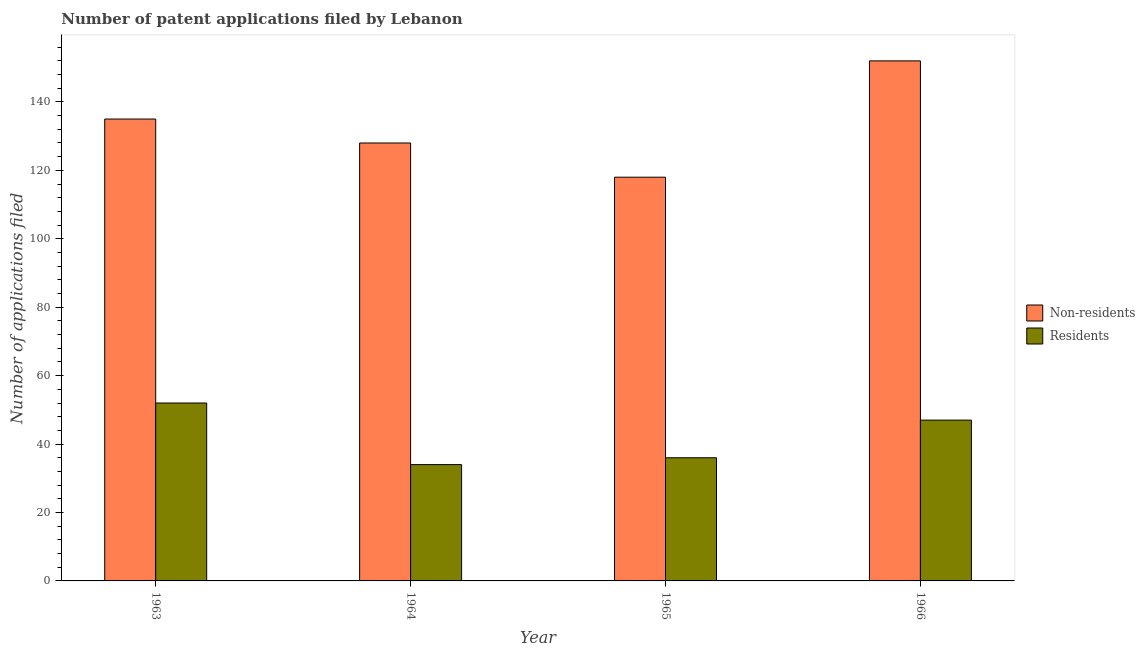How many different coloured bars are there?
Ensure brevity in your answer.  2. How many groups of bars are there?
Your answer should be very brief. 4. How many bars are there on the 1st tick from the left?
Offer a very short reply. 2. How many bars are there on the 2nd tick from the right?
Provide a short and direct response. 2. What is the label of the 3rd group of bars from the left?
Your answer should be very brief. 1965. What is the number of patent applications by non residents in 1965?
Your response must be concise. 118. Across all years, what is the maximum number of patent applications by residents?
Your answer should be very brief. 52. Across all years, what is the minimum number of patent applications by residents?
Offer a terse response. 34. In which year was the number of patent applications by residents maximum?
Offer a terse response. 1963. In which year was the number of patent applications by residents minimum?
Offer a very short reply. 1964. What is the total number of patent applications by residents in the graph?
Your response must be concise. 169. What is the difference between the number of patent applications by non residents in 1965 and that in 1966?
Your answer should be compact. -34. What is the difference between the number of patent applications by residents in 1965 and the number of patent applications by non residents in 1966?
Offer a very short reply. -11. What is the average number of patent applications by non residents per year?
Your answer should be compact. 133.25. What is the ratio of the number of patent applications by non residents in 1963 to that in 1965?
Make the answer very short. 1.14. Is the number of patent applications by non residents in 1964 less than that in 1965?
Make the answer very short. No. What is the difference between the highest and the second highest number of patent applications by residents?
Provide a short and direct response. 5. What is the difference between the highest and the lowest number of patent applications by non residents?
Offer a very short reply. 34. What does the 2nd bar from the left in 1964 represents?
Ensure brevity in your answer.  Residents. What does the 2nd bar from the right in 1966 represents?
Give a very brief answer. Non-residents. How many bars are there?
Your answer should be very brief. 8. What is the difference between two consecutive major ticks on the Y-axis?
Keep it short and to the point. 20. Are the values on the major ticks of Y-axis written in scientific E-notation?
Ensure brevity in your answer.  No. Does the graph contain any zero values?
Make the answer very short. No. Does the graph contain grids?
Offer a very short reply. No. How are the legend labels stacked?
Make the answer very short. Vertical. What is the title of the graph?
Keep it short and to the point. Number of patent applications filed by Lebanon. Does "Resident workers" appear as one of the legend labels in the graph?
Give a very brief answer. No. What is the label or title of the Y-axis?
Give a very brief answer. Number of applications filed. What is the Number of applications filed in Non-residents in 1963?
Give a very brief answer. 135. What is the Number of applications filed in Non-residents in 1964?
Your response must be concise. 128. What is the Number of applications filed in Residents in 1964?
Your response must be concise. 34. What is the Number of applications filed of Non-residents in 1965?
Offer a terse response. 118. What is the Number of applications filed of Non-residents in 1966?
Provide a short and direct response. 152. What is the Number of applications filed in Residents in 1966?
Make the answer very short. 47. Across all years, what is the maximum Number of applications filed in Non-residents?
Provide a short and direct response. 152. Across all years, what is the minimum Number of applications filed in Non-residents?
Offer a very short reply. 118. What is the total Number of applications filed of Non-residents in the graph?
Provide a succinct answer. 533. What is the total Number of applications filed in Residents in the graph?
Your response must be concise. 169. What is the difference between the Number of applications filed of Non-residents in 1963 and that in 1964?
Make the answer very short. 7. What is the difference between the Number of applications filed in Residents in 1963 and that in 1965?
Offer a terse response. 16. What is the difference between the Number of applications filed of Non-residents in 1963 and that in 1966?
Give a very brief answer. -17. What is the difference between the Number of applications filed of Residents in 1963 and that in 1966?
Make the answer very short. 5. What is the difference between the Number of applications filed in Residents in 1964 and that in 1966?
Ensure brevity in your answer.  -13. What is the difference between the Number of applications filed in Non-residents in 1965 and that in 1966?
Offer a terse response. -34. What is the difference between the Number of applications filed in Residents in 1965 and that in 1966?
Give a very brief answer. -11. What is the difference between the Number of applications filed in Non-residents in 1963 and the Number of applications filed in Residents in 1964?
Offer a very short reply. 101. What is the difference between the Number of applications filed in Non-residents in 1963 and the Number of applications filed in Residents in 1965?
Offer a very short reply. 99. What is the difference between the Number of applications filed of Non-residents in 1964 and the Number of applications filed of Residents in 1965?
Your answer should be compact. 92. What is the average Number of applications filed of Non-residents per year?
Your answer should be very brief. 133.25. What is the average Number of applications filed in Residents per year?
Provide a succinct answer. 42.25. In the year 1963, what is the difference between the Number of applications filed in Non-residents and Number of applications filed in Residents?
Your answer should be compact. 83. In the year 1964, what is the difference between the Number of applications filed of Non-residents and Number of applications filed of Residents?
Your answer should be compact. 94. In the year 1966, what is the difference between the Number of applications filed in Non-residents and Number of applications filed in Residents?
Keep it short and to the point. 105. What is the ratio of the Number of applications filed of Non-residents in 1963 to that in 1964?
Your answer should be very brief. 1.05. What is the ratio of the Number of applications filed in Residents in 1963 to that in 1964?
Provide a short and direct response. 1.53. What is the ratio of the Number of applications filed in Non-residents in 1963 to that in 1965?
Provide a short and direct response. 1.14. What is the ratio of the Number of applications filed of Residents in 1963 to that in 1965?
Provide a short and direct response. 1.44. What is the ratio of the Number of applications filed of Non-residents in 1963 to that in 1966?
Give a very brief answer. 0.89. What is the ratio of the Number of applications filed of Residents in 1963 to that in 1966?
Ensure brevity in your answer.  1.11. What is the ratio of the Number of applications filed of Non-residents in 1964 to that in 1965?
Your answer should be compact. 1.08. What is the ratio of the Number of applications filed of Non-residents in 1964 to that in 1966?
Your response must be concise. 0.84. What is the ratio of the Number of applications filed of Residents in 1964 to that in 1966?
Make the answer very short. 0.72. What is the ratio of the Number of applications filed of Non-residents in 1965 to that in 1966?
Offer a terse response. 0.78. What is the ratio of the Number of applications filed in Residents in 1965 to that in 1966?
Your response must be concise. 0.77. What is the difference between the highest and the second highest Number of applications filed in Non-residents?
Your response must be concise. 17. What is the difference between the highest and the lowest Number of applications filed in Non-residents?
Give a very brief answer. 34. 